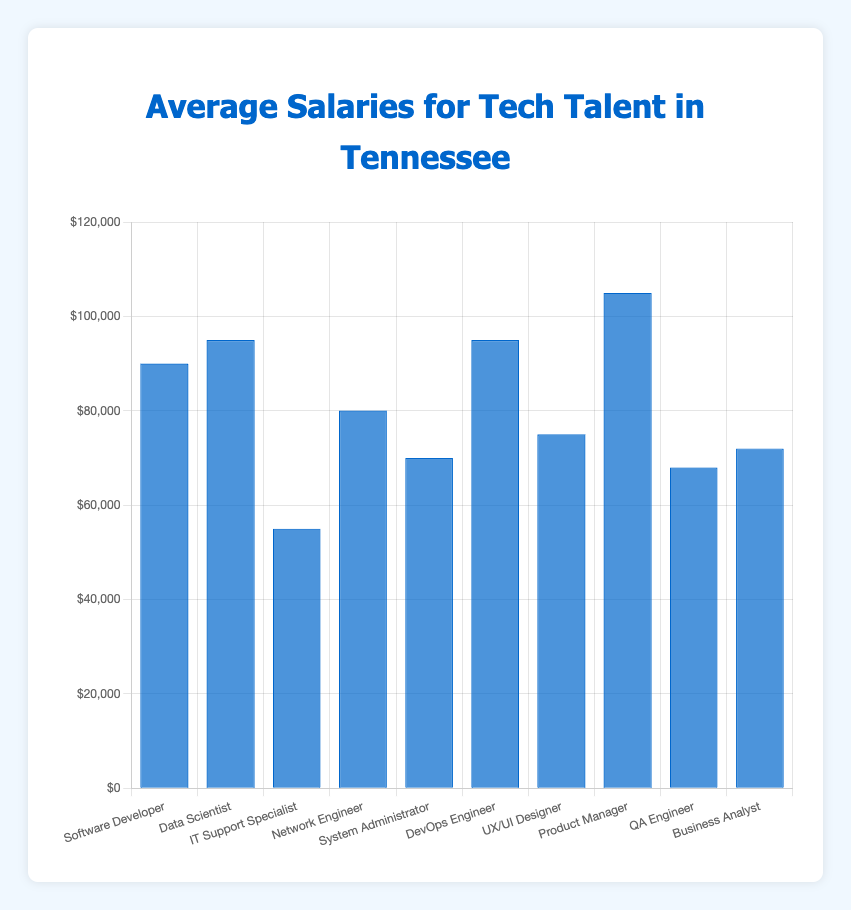What is the average salary for Data Scientists in Tennessee? Referring to the bar labeled "Data Scientist" in the figure, the height represents their average salary.
Answer: $95,000 Which job role has the highest average salary? Look for the tallest bar in the chart, which represents the highest average salary. The "Product Manager" bar is the tallest.
Answer: Product Manager How much more does a DevOps Engineer earn on average compared to a UX/UI Designer? The average salary for a DevOps Engineer is $95,000, and that for a UX/UI Designer is $75,000. Subtract the latter from the former: $95,000 - $75,000
Answer: $20,000 What is the total combined average salary for IT Support Specialists and QA Engineers? The average salary for IT Support Specialists is $55,000, and for QA Engineers it is $68,000. Sum these values: $55,000 + $68,000
Answer: $123,000 Which two job roles have the same average salary? Check the bars for identical heights. Both "Data Scientist" and "DevOps Engineer" have bars at $95,000.
Answer: Data Scientist, DevOps Engineer What is the average salary difference between the highest and lowest paying job roles? The highest paying job role is "Product Manager" at $105,000, and the lowest is "IT Support Specialist" at $55,000. Subtract the latter from the former: $105,000 - $55,000
Answer: $50,000 Rank the job roles from highest to lowest average salary. Arrange the bars from the tallest to the shortest: Product Manager, Data Scientist/DevOps Engineer (tie), Software Developer, Network Engineer, UX/UI Designer, Business Analyst, System Administrator, QA Engineer, IT Support Specialist.
Answer: Product Manager, Data Scientist/DevOps Engineer, Software Developer, Network Engineer, UX/UI Designer, Business Analyst, System Administrator, QA Engineer, IT Support Specialist How does the average salary of a System Administrator compare to that of a Network Engineer? Identify the heights of the bars: System Administrator is $70,000 and Network Engineer is $80,000. Network Engineer's average salary is higher.
Answer: Network Engineer earns more Which job role's average salary is closest to $60,000? Check the bars and find the one nearest to $60,000. "QA Engineer" at $68,000 is the closest.
Answer: QA Engineer What is the combined average salary of Software Developer, Data Scientist, and DevOps Engineer? Add the average salaries: Software Developer ($90,000), Data Scientist ($95,000), DevOps Engineer ($95,000): $90,000 + $95,000 + $95,000
Answer: $280,000 